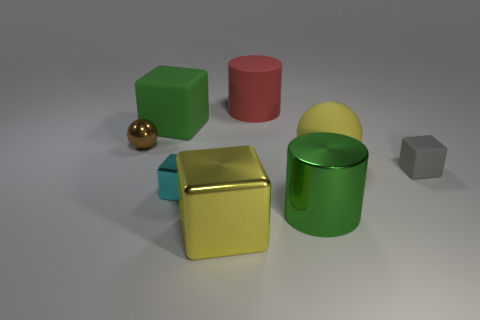What shape is the shiny object that is the same color as the big ball?
Provide a succinct answer. Cube. Is the shape of the object that is behind the green block the same as the green object on the right side of the big red object?
Provide a succinct answer. Yes. How many other things are there of the same size as the green rubber object?
Offer a terse response. 4. Does the large metallic cube have the same color as the matte cube in front of the tiny sphere?
Ensure brevity in your answer.  No. Is the number of green matte objects on the right side of the green metallic cylinder less than the number of large yellow things to the left of the yellow sphere?
Ensure brevity in your answer.  Yes. What color is the object that is on the left side of the cyan metal thing and right of the brown metallic sphere?
Keep it short and to the point. Green. There is a red matte thing; is it the same size as the yellow ball that is right of the large green cylinder?
Offer a terse response. Yes. There is a metal object that is behind the cyan object; what shape is it?
Your answer should be compact. Sphere. Is the number of metal things that are on the left side of the large red rubber object greater than the number of big rubber cylinders?
Ensure brevity in your answer.  Yes. There is a metallic thing that is behind the ball that is to the right of the metal ball; how many green things are in front of it?
Ensure brevity in your answer.  1. 